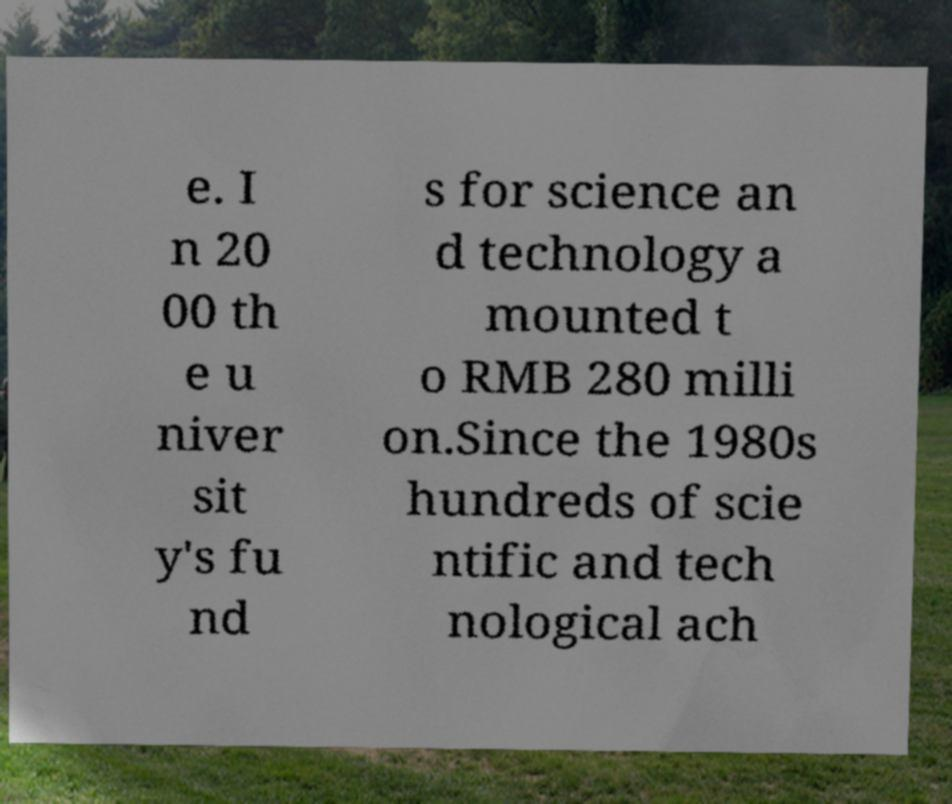Could you extract and type out the text from this image? e. I n 20 00 th e u niver sit y's fu nd s for science an d technology a mounted t o RMB 280 milli on.Since the 1980s hundreds of scie ntific and tech nological ach 